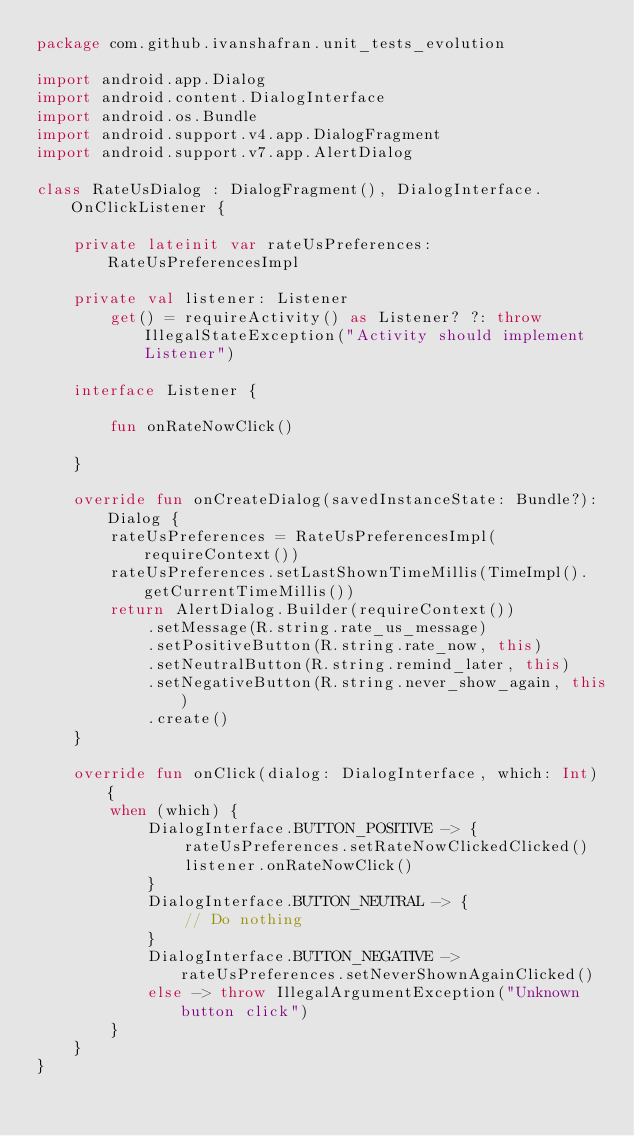Convert code to text. <code><loc_0><loc_0><loc_500><loc_500><_Kotlin_>package com.github.ivanshafran.unit_tests_evolution

import android.app.Dialog
import android.content.DialogInterface
import android.os.Bundle
import android.support.v4.app.DialogFragment
import android.support.v7.app.AlertDialog

class RateUsDialog : DialogFragment(), DialogInterface.OnClickListener {

    private lateinit var rateUsPreferences: RateUsPreferencesImpl

    private val listener: Listener
        get() = requireActivity() as Listener? ?: throw IllegalStateException("Activity should implement Listener")

    interface Listener {

        fun onRateNowClick()

    }

    override fun onCreateDialog(savedInstanceState: Bundle?): Dialog {
        rateUsPreferences = RateUsPreferencesImpl(requireContext())
        rateUsPreferences.setLastShownTimeMillis(TimeImpl().getCurrentTimeMillis())
        return AlertDialog.Builder(requireContext())
            .setMessage(R.string.rate_us_message)
            .setPositiveButton(R.string.rate_now, this)
            .setNeutralButton(R.string.remind_later, this)
            .setNegativeButton(R.string.never_show_again, this)
            .create()
    }

    override fun onClick(dialog: DialogInterface, which: Int) {
        when (which) {
            DialogInterface.BUTTON_POSITIVE -> {
                rateUsPreferences.setRateNowClickedClicked()
                listener.onRateNowClick()
            }
            DialogInterface.BUTTON_NEUTRAL -> {
                // Do nothing
            }
            DialogInterface.BUTTON_NEGATIVE -> rateUsPreferences.setNeverShownAgainClicked()
            else -> throw IllegalArgumentException("Unknown button click")
        }
    }
}
</code> 